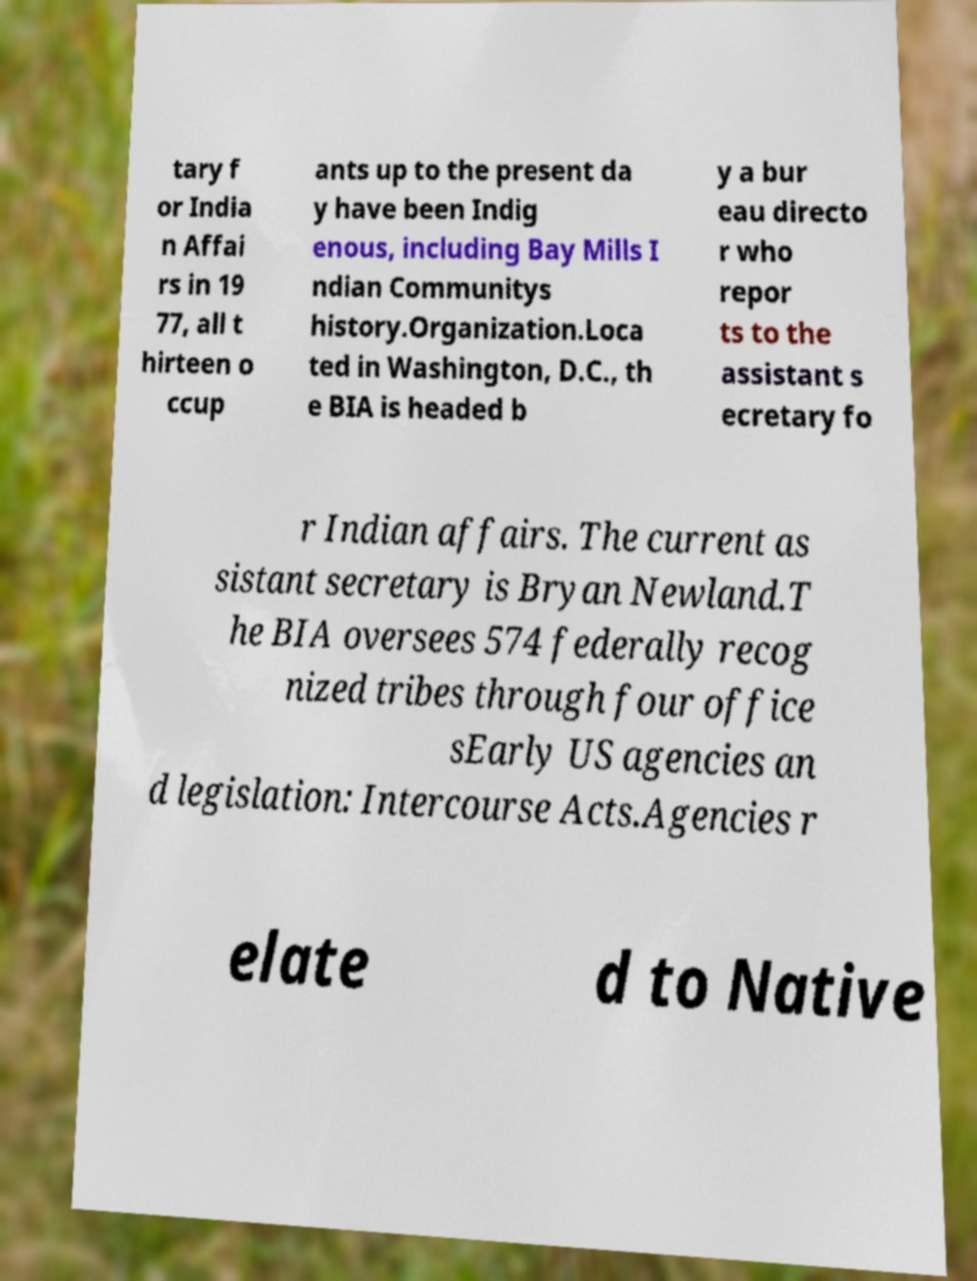What messages or text are displayed in this image? I need them in a readable, typed format. tary f or India n Affai rs in 19 77, all t hirteen o ccup ants up to the present da y have been Indig enous, including Bay Mills I ndian Communitys history.Organization.Loca ted in Washington, D.C., th e BIA is headed b y a bur eau directo r who repor ts to the assistant s ecretary fo r Indian affairs. The current as sistant secretary is Bryan Newland.T he BIA oversees 574 federally recog nized tribes through four office sEarly US agencies an d legislation: Intercourse Acts.Agencies r elate d to Native 